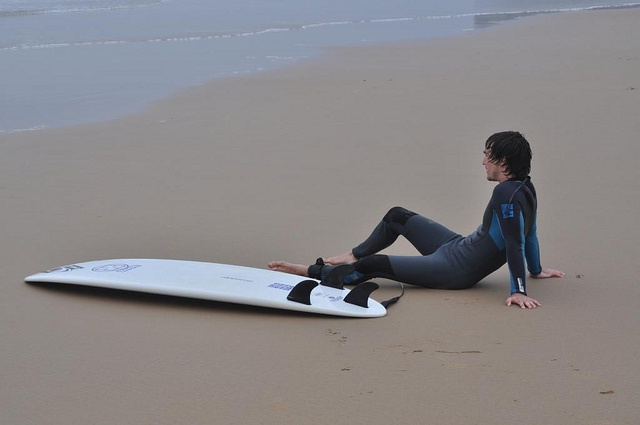Describe the objects in this image and their specific colors. I can see people in darkgray, black, navy, and gray tones and surfboard in darkgray, lightblue, lavender, and black tones in this image. 